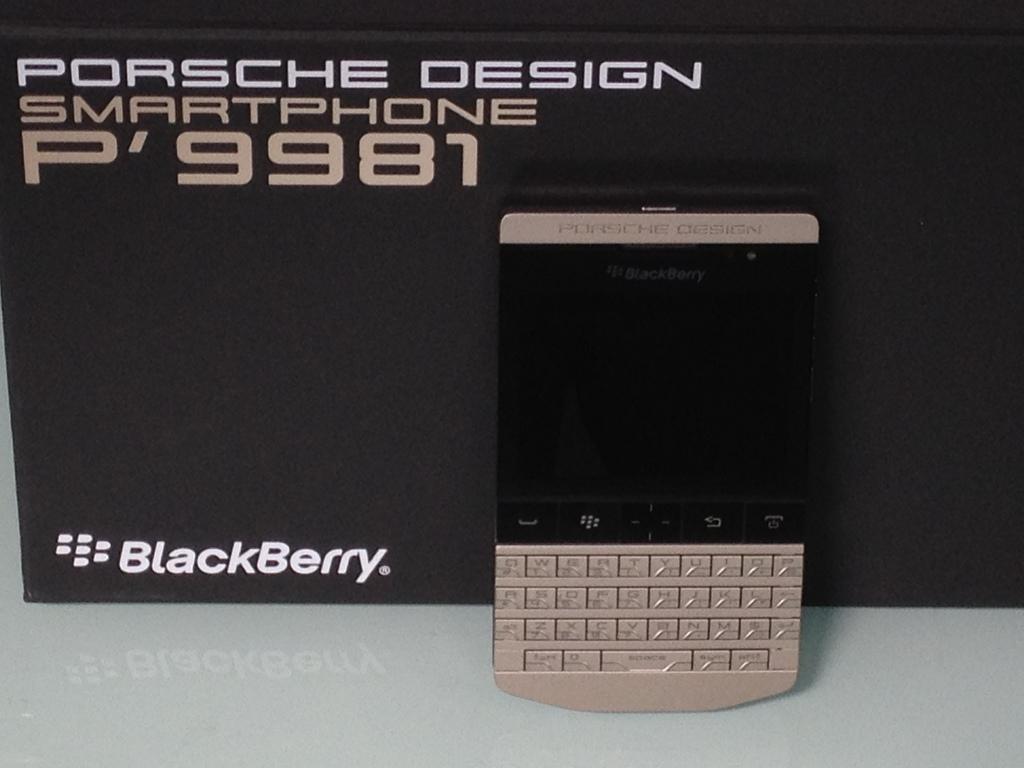What kind of smartphone is this?
Keep it short and to the point. Blackberry. Who owns this bb phone?
Provide a short and direct response. Blackberry. 